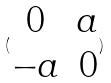<formula> <loc_0><loc_0><loc_500><loc_500>( \begin{matrix} 0 & a \\ - a & 0 \end{matrix} )</formula> 